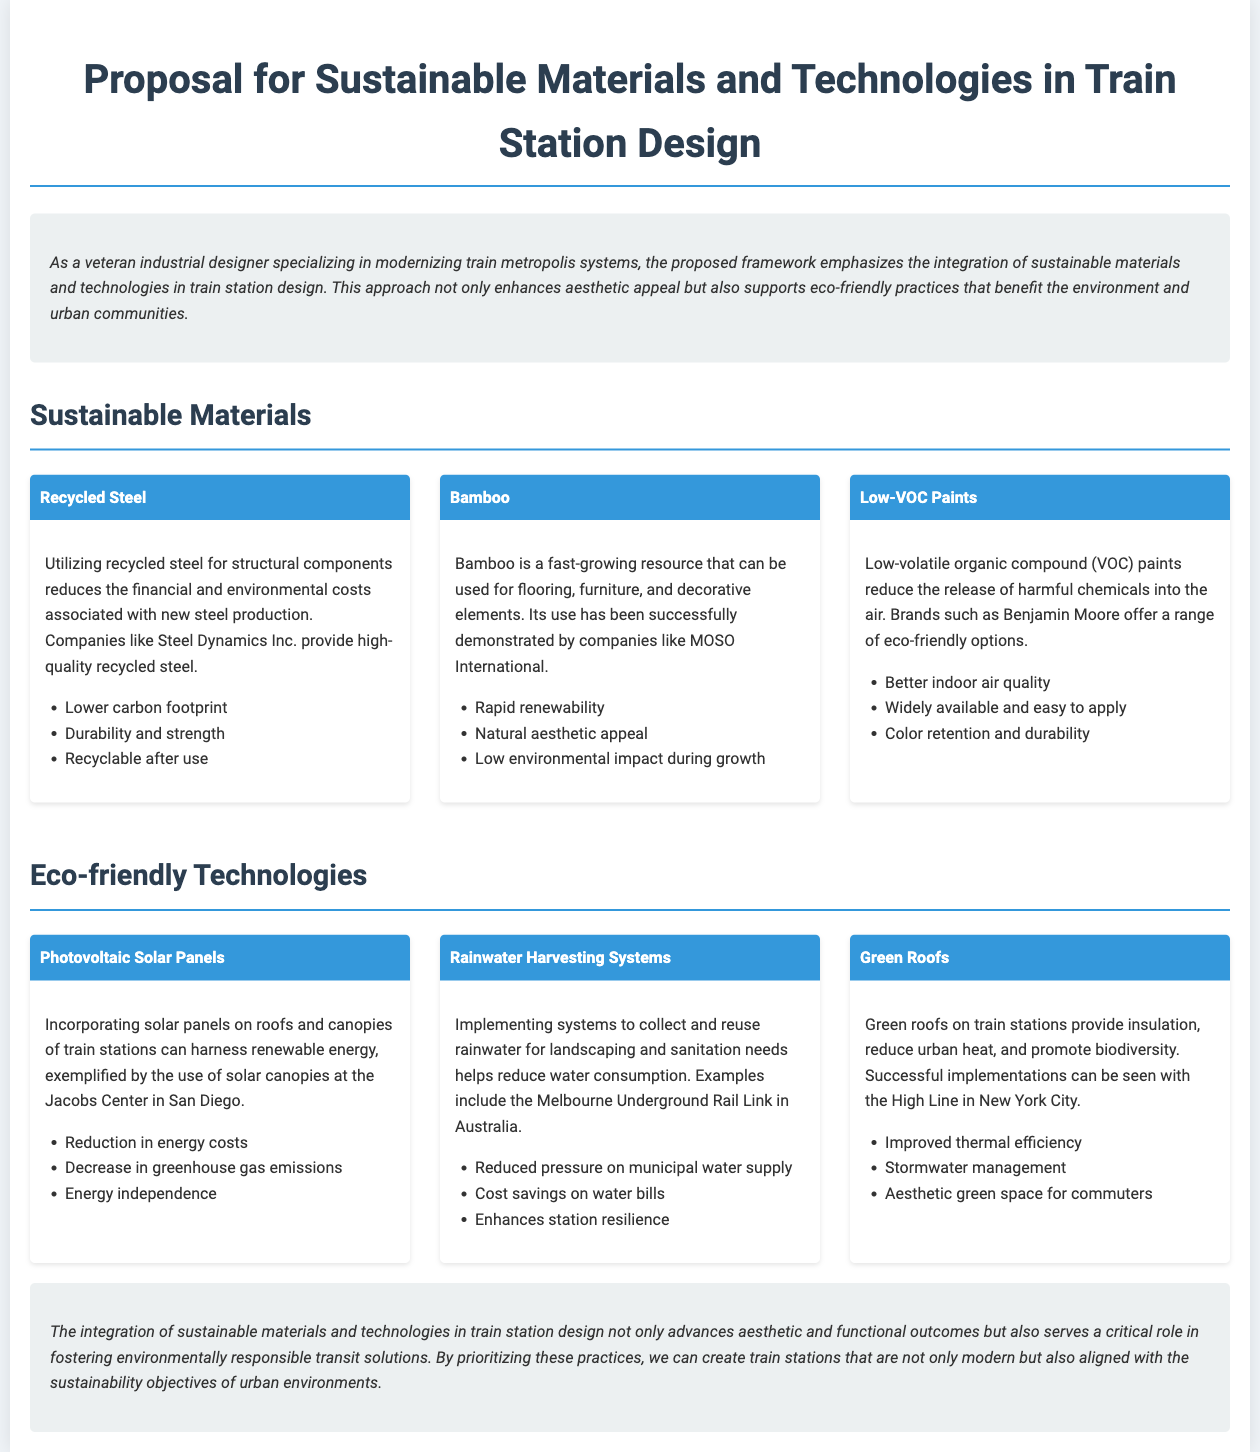What type of materials does the proposal emphasize? The proposal emphasizes the integration of sustainable materials and technologies, specifically mentioning materials such as recycled steel and bamboo.
Answer: Sustainable materials Who is mentioned as a supplier of recycled steel? The document mentions Steel Dynamics Inc. as a provider of high-quality recycled steel for structural components.
Answer: Steel Dynamics Inc What type of paints are recommended for train station design? The document recommends low-volatile organic compound (VOC) paints to reduce harmful chemical emissions.
Answer: Low-VOC Paints What is one benefit of photovoltaic solar panels listed in the proposal? One benefit highlighted is the reduction in energy costs achieved through the use of solar panels.
Answer: Reduction in energy costs Which sustainable technology is associated with the Melbourne Underground Rail Link? The document associates rainwater harvesting systems with the Melbourne Underground Rail Link as an example of implementing eco-friendly technology.
Answer: Rainwater Harvesting Systems What is the main purpose of using green roofs on train stations? The main purpose of green roofs is to provide insulation, reduce urban heat, and promote biodiversity.
Answer: Provide insulation How does bamboo contribute to eco-friendly design? Bamboo is a fast-growing resource that has a low environmental impact during growth and offers a natural aesthetic.
Answer: Rapid renewability What is the overall goal of the proposal? The overall goal is to integrate sustainable materials and technologies in train station design for environmental responsibility and modern aesthetics.
Answer: Environmental responsibility 